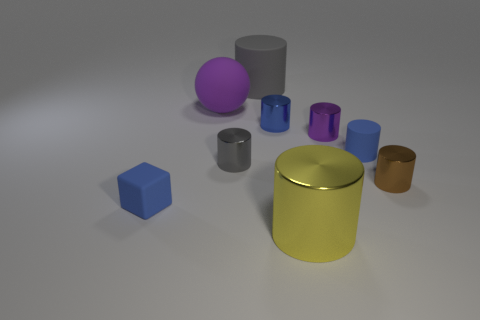How many rubber spheres have the same size as the gray metallic cylinder?
Your answer should be compact. 0. What is the color of the big cylinder that is made of the same material as the tiny brown object?
Your response must be concise. Yellow. Are there more small yellow cylinders than blue cylinders?
Make the answer very short. No. Do the brown cylinder and the big gray thing have the same material?
Offer a terse response. No. There is a large object that is the same material as the big gray cylinder; what is its shape?
Offer a terse response. Sphere. Is the number of things less than the number of big yellow cubes?
Make the answer very short. No. There is a small blue object that is behind the tiny blue block and to the left of the big metallic cylinder; what material is it made of?
Your answer should be compact. Metal. There is a metal cylinder that is in front of the small blue rubber thing in front of the gray cylinder that is in front of the ball; what is its size?
Your response must be concise. Large. There is a tiny brown metallic object; does it have the same shape as the big object that is right of the gray matte cylinder?
Provide a short and direct response. Yes. How many tiny objects are in front of the small purple shiny thing and on the right side of the large rubber cylinder?
Your response must be concise. 2. 